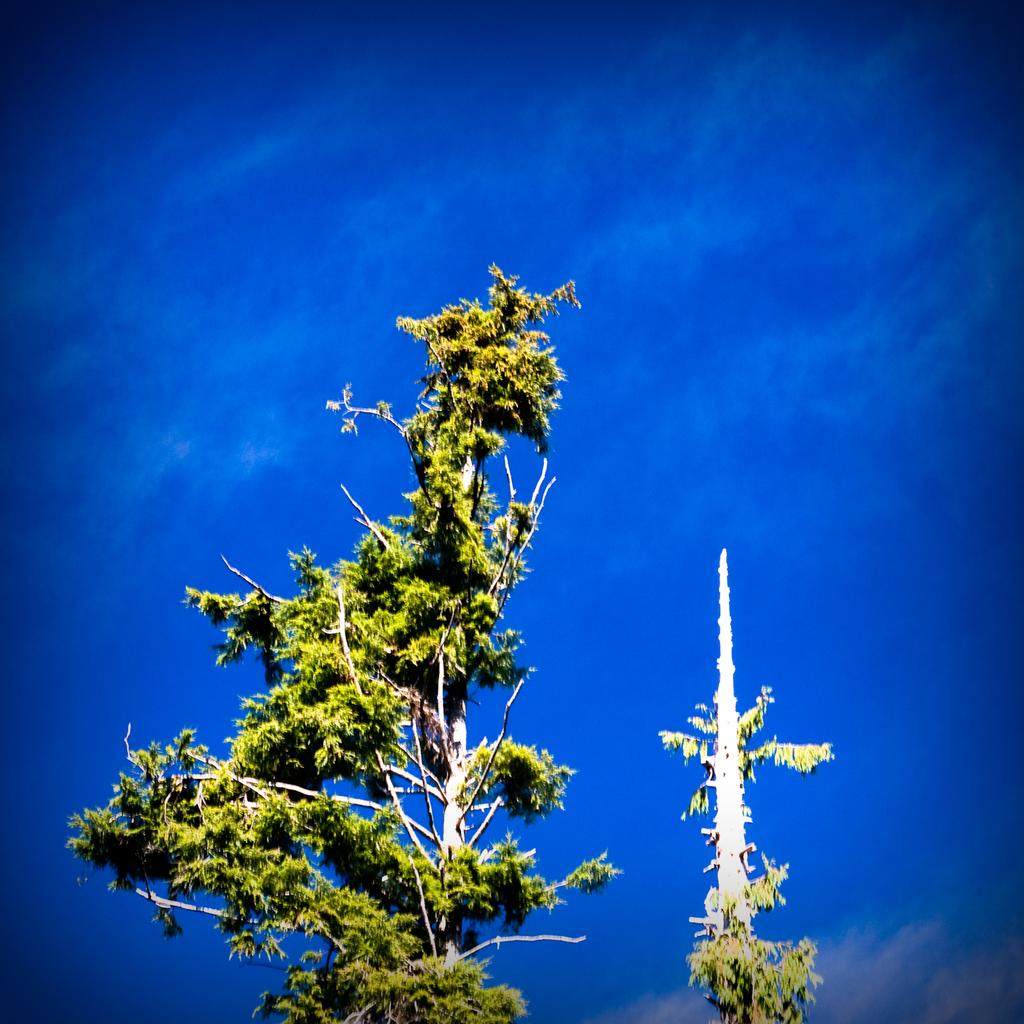What is located in the center of the image? There are trees in the center of the image. What can be seen in the background of the image? There is a sky visible in the background of the image. What degree does the rhythm of the trees have in the image? The image does not depict any rhythm or degrees related to the trees. 